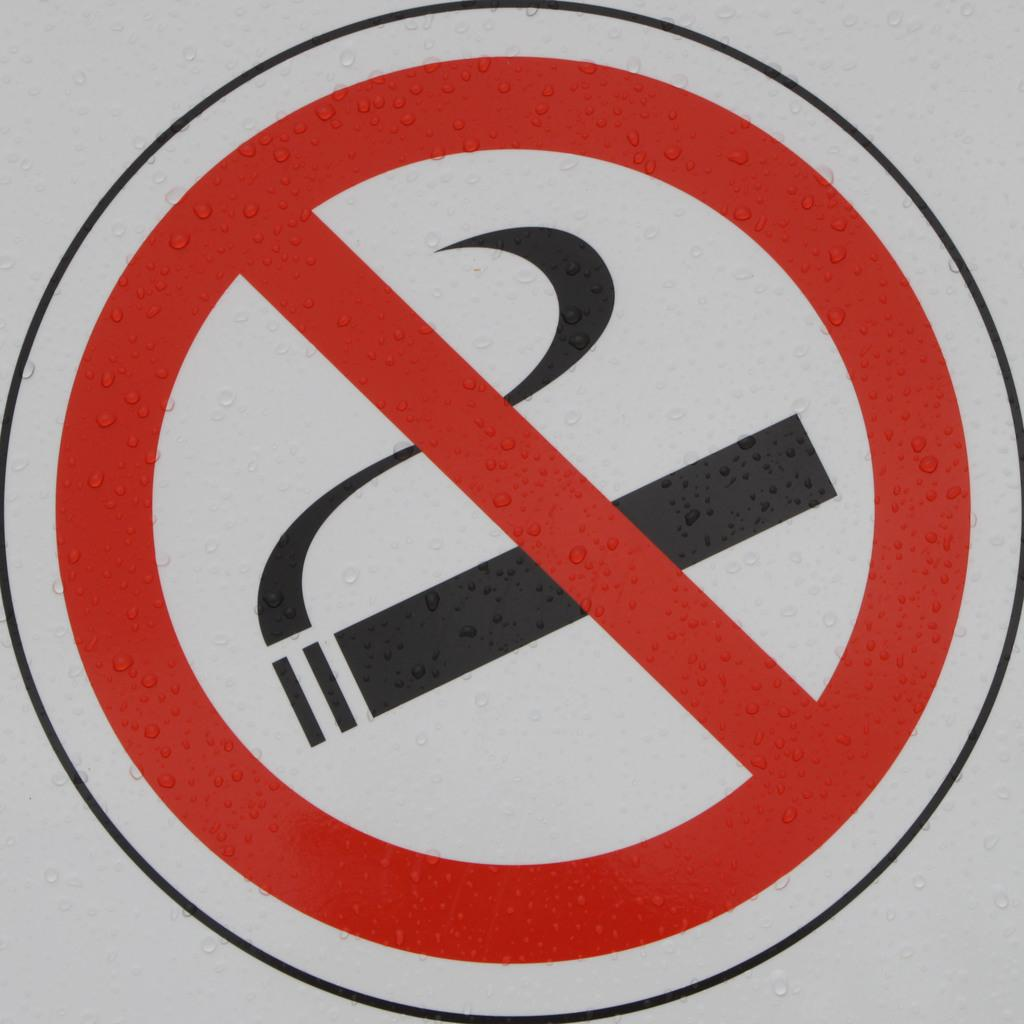What is the main subject of the image? The main subject of the image is a no smoking symbol. Can you describe the symbol in the image? The no smoking symbol is in the center of the image. What type of verse is recited by the eggnog in the image? There is no eggnog or verse present in the image; it only features a no smoking symbol. 